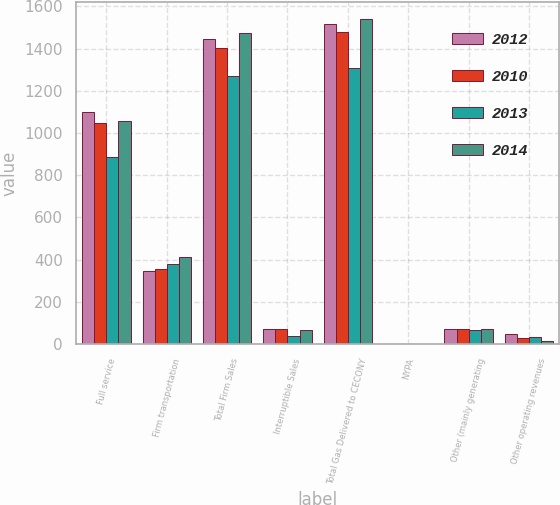Convert chart to OTSL. <chart><loc_0><loc_0><loc_500><loc_500><stacked_bar_chart><ecel><fcel>Full service<fcel>Firm transportation<fcel>Total Firm Sales<fcel>Interruptible Sales<fcel>Total Gas Delivered to CECONY<fcel>NYPA<fcel>Other (mainly generating<fcel>Other operating revenues<nl><fcel>2012<fcel>1099<fcel>347<fcel>1446<fcel>72<fcel>1518<fcel>2<fcel>71<fcel>50<nl><fcel>2010<fcel>1048<fcel>356<fcel>1404<fcel>74<fcel>1478<fcel>2<fcel>71<fcel>30<nl><fcel>2013<fcel>889<fcel>380<fcel>1269<fcel>39<fcel>1308<fcel>2<fcel>68<fcel>32<nl><fcel>2014<fcel>1059<fcel>414<fcel>1473<fcel>69<fcel>1542<fcel>2<fcel>71<fcel>17<nl></chart> 